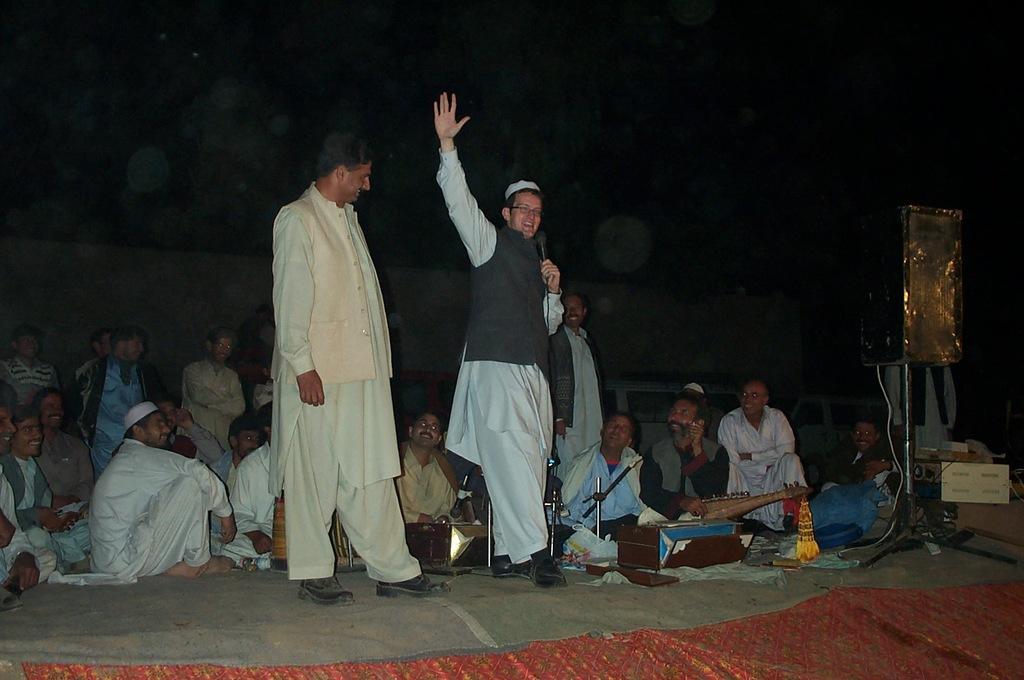Please provide a concise description of this image. In this image we can see a group of people sitting on the floor. A person is speaking into a microphone. There are few people are playing musical instruments. There is a loudspeaker in the image. 